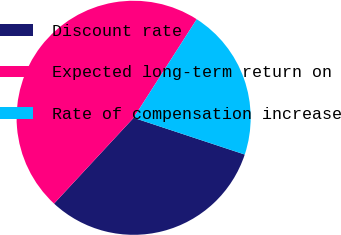Convert chart to OTSL. <chart><loc_0><loc_0><loc_500><loc_500><pie_chart><fcel>Discount rate<fcel>Expected long-term return on<fcel>Rate of compensation increase<nl><fcel>31.82%<fcel>47.16%<fcel>21.02%<nl></chart> 